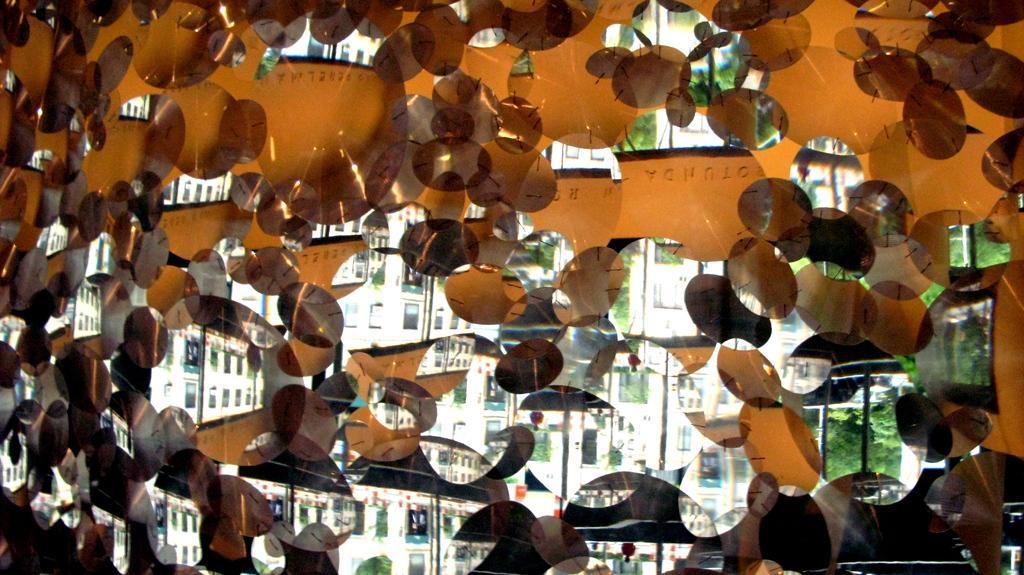Describe this image in one or two sentences. This is an edited image. To the right side of the image there are trees. To the left side of the image there are buildings. 